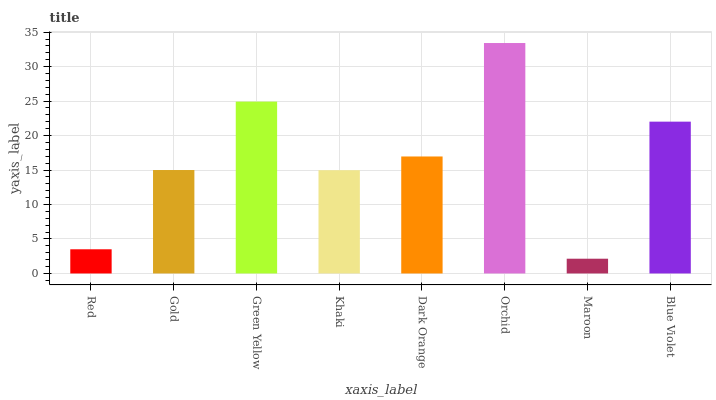Is Gold the minimum?
Answer yes or no. No. Is Gold the maximum?
Answer yes or no. No. Is Gold greater than Red?
Answer yes or no. Yes. Is Red less than Gold?
Answer yes or no. Yes. Is Red greater than Gold?
Answer yes or no. No. Is Gold less than Red?
Answer yes or no. No. Is Dark Orange the high median?
Answer yes or no. Yes. Is Gold the low median?
Answer yes or no. Yes. Is Maroon the high median?
Answer yes or no. No. Is Orchid the low median?
Answer yes or no. No. 